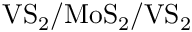<formula> <loc_0><loc_0><loc_500><loc_500>V S _ { 2 } / M o S _ { 2 } / V S _ { 2 }</formula> 